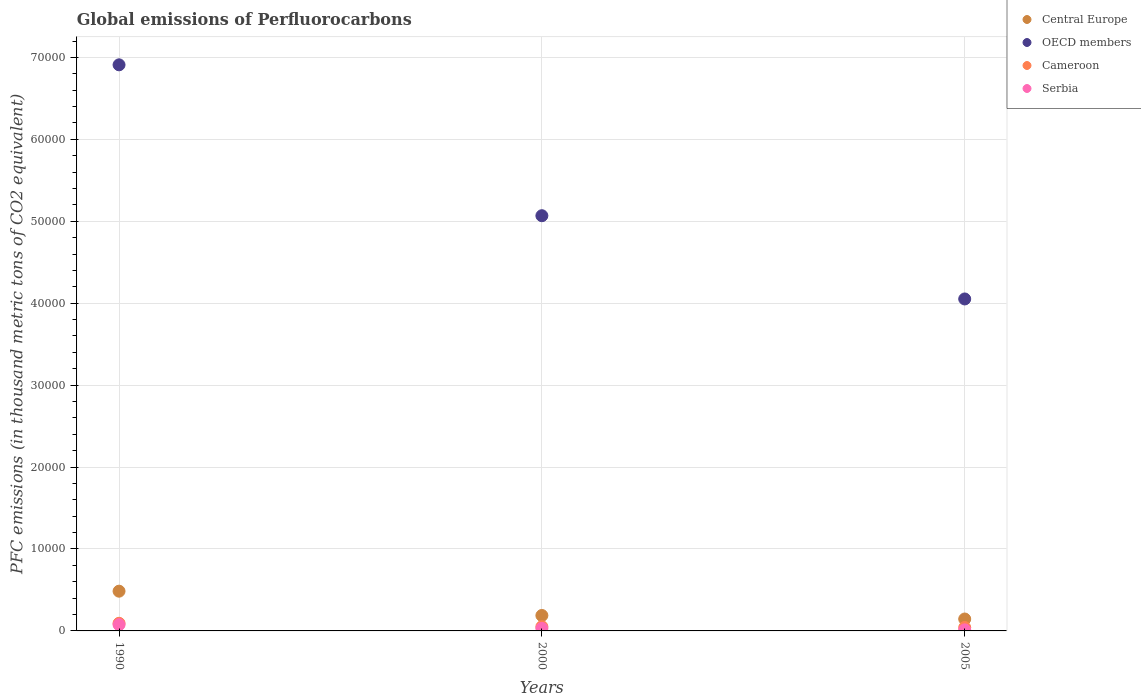Is the number of dotlines equal to the number of legend labels?
Your answer should be compact. Yes. What is the global emissions of Perfluorocarbons in OECD members in 2005?
Your answer should be compact. 4.05e+04. Across all years, what is the maximum global emissions of Perfluorocarbons in Cameroon?
Ensure brevity in your answer.  932.3. Across all years, what is the minimum global emissions of Perfluorocarbons in Cameroon?
Keep it short and to the point. 417.5. In which year was the global emissions of Perfluorocarbons in Cameroon maximum?
Your answer should be very brief. 1990. What is the total global emissions of Perfluorocarbons in Serbia in the graph?
Make the answer very short. 1197. What is the difference between the global emissions of Perfluorocarbons in Cameroon in 1990 and that in 2005?
Make the answer very short. 514.8. What is the difference between the global emissions of Perfluorocarbons in Serbia in 1990 and the global emissions of Perfluorocarbons in OECD members in 2000?
Offer a terse response. -4.99e+04. What is the average global emissions of Perfluorocarbons in OECD members per year?
Give a very brief answer. 5.34e+04. In the year 2005, what is the difference between the global emissions of Perfluorocarbons in OECD members and global emissions of Perfluorocarbons in Serbia?
Your answer should be very brief. 4.04e+04. What is the ratio of the global emissions of Perfluorocarbons in OECD members in 1990 to that in 2000?
Provide a short and direct response. 1.36. Is the global emissions of Perfluorocarbons in Serbia in 1990 less than that in 2005?
Provide a short and direct response. No. Is the difference between the global emissions of Perfluorocarbons in OECD members in 1990 and 2005 greater than the difference between the global emissions of Perfluorocarbons in Serbia in 1990 and 2005?
Your response must be concise. Yes. What is the difference between the highest and the second highest global emissions of Perfluorocarbons in OECD members?
Your answer should be compact. 1.84e+04. What is the difference between the highest and the lowest global emissions of Perfluorocarbons in Central Europe?
Give a very brief answer. 3396.8. Is the sum of the global emissions of Perfluorocarbons in Central Europe in 1990 and 2005 greater than the maximum global emissions of Perfluorocarbons in Cameroon across all years?
Give a very brief answer. Yes. Is it the case that in every year, the sum of the global emissions of Perfluorocarbons in Cameroon and global emissions of Perfluorocarbons in Serbia  is greater than the sum of global emissions of Perfluorocarbons in OECD members and global emissions of Perfluorocarbons in Central Europe?
Keep it short and to the point. No. Is it the case that in every year, the sum of the global emissions of Perfluorocarbons in Cameroon and global emissions of Perfluorocarbons in Serbia  is greater than the global emissions of Perfluorocarbons in OECD members?
Give a very brief answer. No. Does the global emissions of Perfluorocarbons in Cameroon monotonically increase over the years?
Your answer should be very brief. No. Is the global emissions of Perfluorocarbons in Serbia strictly less than the global emissions of Perfluorocarbons in OECD members over the years?
Make the answer very short. Yes. How many years are there in the graph?
Your answer should be compact. 3. Are the values on the major ticks of Y-axis written in scientific E-notation?
Your answer should be compact. No. How are the legend labels stacked?
Provide a short and direct response. Vertical. What is the title of the graph?
Offer a terse response. Global emissions of Perfluorocarbons. What is the label or title of the Y-axis?
Your answer should be compact. PFC emissions (in thousand metric tons of CO2 equivalent). What is the PFC emissions (in thousand metric tons of CO2 equivalent) of Central Europe in 1990?
Your answer should be compact. 4850.4. What is the PFC emissions (in thousand metric tons of CO2 equivalent) of OECD members in 1990?
Provide a short and direct response. 6.91e+04. What is the PFC emissions (in thousand metric tons of CO2 equivalent) of Cameroon in 1990?
Offer a terse response. 932.3. What is the PFC emissions (in thousand metric tons of CO2 equivalent) in Serbia in 1990?
Provide a short and direct response. 761.9. What is the PFC emissions (in thousand metric tons of CO2 equivalent) of Central Europe in 2000?
Your response must be concise. 1884.7. What is the PFC emissions (in thousand metric tons of CO2 equivalent) of OECD members in 2000?
Your answer should be very brief. 5.07e+04. What is the PFC emissions (in thousand metric tons of CO2 equivalent) of Cameroon in 2000?
Offer a terse response. 514.7. What is the PFC emissions (in thousand metric tons of CO2 equivalent) of Serbia in 2000?
Provide a succinct answer. 306.1. What is the PFC emissions (in thousand metric tons of CO2 equivalent) of Central Europe in 2005?
Provide a succinct answer. 1453.6. What is the PFC emissions (in thousand metric tons of CO2 equivalent) in OECD members in 2005?
Offer a terse response. 4.05e+04. What is the PFC emissions (in thousand metric tons of CO2 equivalent) in Cameroon in 2005?
Offer a very short reply. 417.5. What is the PFC emissions (in thousand metric tons of CO2 equivalent) in Serbia in 2005?
Make the answer very short. 129. Across all years, what is the maximum PFC emissions (in thousand metric tons of CO2 equivalent) in Central Europe?
Your answer should be very brief. 4850.4. Across all years, what is the maximum PFC emissions (in thousand metric tons of CO2 equivalent) in OECD members?
Ensure brevity in your answer.  6.91e+04. Across all years, what is the maximum PFC emissions (in thousand metric tons of CO2 equivalent) of Cameroon?
Give a very brief answer. 932.3. Across all years, what is the maximum PFC emissions (in thousand metric tons of CO2 equivalent) of Serbia?
Your answer should be very brief. 761.9. Across all years, what is the minimum PFC emissions (in thousand metric tons of CO2 equivalent) in Central Europe?
Your answer should be compact. 1453.6. Across all years, what is the minimum PFC emissions (in thousand metric tons of CO2 equivalent) of OECD members?
Your answer should be very brief. 4.05e+04. Across all years, what is the minimum PFC emissions (in thousand metric tons of CO2 equivalent) in Cameroon?
Make the answer very short. 417.5. Across all years, what is the minimum PFC emissions (in thousand metric tons of CO2 equivalent) of Serbia?
Keep it short and to the point. 129. What is the total PFC emissions (in thousand metric tons of CO2 equivalent) of Central Europe in the graph?
Your response must be concise. 8188.7. What is the total PFC emissions (in thousand metric tons of CO2 equivalent) in OECD members in the graph?
Keep it short and to the point. 1.60e+05. What is the total PFC emissions (in thousand metric tons of CO2 equivalent) in Cameroon in the graph?
Your answer should be very brief. 1864.5. What is the total PFC emissions (in thousand metric tons of CO2 equivalent) of Serbia in the graph?
Provide a short and direct response. 1197. What is the difference between the PFC emissions (in thousand metric tons of CO2 equivalent) in Central Europe in 1990 and that in 2000?
Give a very brief answer. 2965.7. What is the difference between the PFC emissions (in thousand metric tons of CO2 equivalent) in OECD members in 1990 and that in 2000?
Your response must be concise. 1.84e+04. What is the difference between the PFC emissions (in thousand metric tons of CO2 equivalent) in Cameroon in 1990 and that in 2000?
Provide a succinct answer. 417.6. What is the difference between the PFC emissions (in thousand metric tons of CO2 equivalent) in Serbia in 1990 and that in 2000?
Your answer should be very brief. 455.8. What is the difference between the PFC emissions (in thousand metric tons of CO2 equivalent) of Central Europe in 1990 and that in 2005?
Offer a terse response. 3396.8. What is the difference between the PFC emissions (in thousand metric tons of CO2 equivalent) of OECD members in 1990 and that in 2005?
Your answer should be compact. 2.86e+04. What is the difference between the PFC emissions (in thousand metric tons of CO2 equivalent) of Cameroon in 1990 and that in 2005?
Your answer should be compact. 514.8. What is the difference between the PFC emissions (in thousand metric tons of CO2 equivalent) of Serbia in 1990 and that in 2005?
Your response must be concise. 632.9. What is the difference between the PFC emissions (in thousand metric tons of CO2 equivalent) in Central Europe in 2000 and that in 2005?
Your answer should be compact. 431.1. What is the difference between the PFC emissions (in thousand metric tons of CO2 equivalent) in OECD members in 2000 and that in 2005?
Provide a succinct answer. 1.02e+04. What is the difference between the PFC emissions (in thousand metric tons of CO2 equivalent) of Cameroon in 2000 and that in 2005?
Keep it short and to the point. 97.2. What is the difference between the PFC emissions (in thousand metric tons of CO2 equivalent) of Serbia in 2000 and that in 2005?
Your response must be concise. 177.1. What is the difference between the PFC emissions (in thousand metric tons of CO2 equivalent) in Central Europe in 1990 and the PFC emissions (in thousand metric tons of CO2 equivalent) in OECD members in 2000?
Offer a very short reply. -4.58e+04. What is the difference between the PFC emissions (in thousand metric tons of CO2 equivalent) in Central Europe in 1990 and the PFC emissions (in thousand metric tons of CO2 equivalent) in Cameroon in 2000?
Offer a very short reply. 4335.7. What is the difference between the PFC emissions (in thousand metric tons of CO2 equivalent) in Central Europe in 1990 and the PFC emissions (in thousand metric tons of CO2 equivalent) in Serbia in 2000?
Ensure brevity in your answer.  4544.3. What is the difference between the PFC emissions (in thousand metric tons of CO2 equivalent) in OECD members in 1990 and the PFC emissions (in thousand metric tons of CO2 equivalent) in Cameroon in 2000?
Your answer should be very brief. 6.86e+04. What is the difference between the PFC emissions (in thousand metric tons of CO2 equivalent) in OECD members in 1990 and the PFC emissions (in thousand metric tons of CO2 equivalent) in Serbia in 2000?
Give a very brief answer. 6.88e+04. What is the difference between the PFC emissions (in thousand metric tons of CO2 equivalent) of Cameroon in 1990 and the PFC emissions (in thousand metric tons of CO2 equivalent) of Serbia in 2000?
Provide a succinct answer. 626.2. What is the difference between the PFC emissions (in thousand metric tons of CO2 equivalent) of Central Europe in 1990 and the PFC emissions (in thousand metric tons of CO2 equivalent) of OECD members in 2005?
Offer a very short reply. -3.57e+04. What is the difference between the PFC emissions (in thousand metric tons of CO2 equivalent) of Central Europe in 1990 and the PFC emissions (in thousand metric tons of CO2 equivalent) of Cameroon in 2005?
Offer a terse response. 4432.9. What is the difference between the PFC emissions (in thousand metric tons of CO2 equivalent) in Central Europe in 1990 and the PFC emissions (in thousand metric tons of CO2 equivalent) in Serbia in 2005?
Give a very brief answer. 4721.4. What is the difference between the PFC emissions (in thousand metric tons of CO2 equivalent) in OECD members in 1990 and the PFC emissions (in thousand metric tons of CO2 equivalent) in Cameroon in 2005?
Ensure brevity in your answer.  6.87e+04. What is the difference between the PFC emissions (in thousand metric tons of CO2 equivalent) in OECD members in 1990 and the PFC emissions (in thousand metric tons of CO2 equivalent) in Serbia in 2005?
Keep it short and to the point. 6.90e+04. What is the difference between the PFC emissions (in thousand metric tons of CO2 equivalent) of Cameroon in 1990 and the PFC emissions (in thousand metric tons of CO2 equivalent) of Serbia in 2005?
Provide a succinct answer. 803.3. What is the difference between the PFC emissions (in thousand metric tons of CO2 equivalent) in Central Europe in 2000 and the PFC emissions (in thousand metric tons of CO2 equivalent) in OECD members in 2005?
Ensure brevity in your answer.  -3.86e+04. What is the difference between the PFC emissions (in thousand metric tons of CO2 equivalent) in Central Europe in 2000 and the PFC emissions (in thousand metric tons of CO2 equivalent) in Cameroon in 2005?
Make the answer very short. 1467.2. What is the difference between the PFC emissions (in thousand metric tons of CO2 equivalent) of Central Europe in 2000 and the PFC emissions (in thousand metric tons of CO2 equivalent) of Serbia in 2005?
Provide a succinct answer. 1755.7. What is the difference between the PFC emissions (in thousand metric tons of CO2 equivalent) of OECD members in 2000 and the PFC emissions (in thousand metric tons of CO2 equivalent) of Cameroon in 2005?
Ensure brevity in your answer.  5.03e+04. What is the difference between the PFC emissions (in thousand metric tons of CO2 equivalent) in OECD members in 2000 and the PFC emissions (in thousand metric tons of CO2 equivalent) in Serbia in 2005?
Give a very brief answer. 5.06e+04. What is the difference between the PFC emissions (in thousand metric tons of CO2 equivalent) in Cameroon in 2000 and the PFC emissions (in thousand metric tons of CO2 equivalent) in Serbia in 2005?
Your answer should be very brief. 385.7. What is the average PFC emissions (in thousand metric tons of CO2 equivalent) in Central Europe per year?
Provide a succinct answer. 2729.57. What is the average PFC emissions (in thousand metric tons of CO2 equivalent) of OECD members per year?
Ensure brevity in your answer.  5.34e+04. What is the average PFC emissions (in thousand metric tons of CO2 equivalent) in Cameroon per year?
Ensure brevity in your answer.  621.5. What is the average PFC emissions (in thousand metric tons of CO2 equivalent) of Serbia per year?
Offer a very short reply. 399. In the year 1990, what is the difference between the PFC emissions (in thousand metric tons of CO2 equivalent) in Central Europe and PFC emissions (in thousand metric tons of CO2 equivalent) in OECD members?
Your answer should be compact. -6.42e+04. In the year 1990, what is the difference between the PFC emissions (in thousand metric tons of CO2 equivalent) in Central Europe and PFC emissions (in thousand metric tons of CO2 equivalent) in Cameroon?
Your answer should be compact. 3918.1. In the year 1990, what is the difference between the PFC emissions (in thousand metric tons of CO2 equivalent) in Central Europe and PFC emissions (in thousand metric tons of CO2 equivalent) in Serbia?
Provide a short and direct response. 4088.5. In the year 1990, what is the difference between the PFC emissions (in thousand metric tons of CO2 equivalent) in OECD members and PFC emissions (in thousand metric tons of CO2 equivalent) in Cameroon?
Your answer should be very brief. 6.82e+04. In the year 1990, what is the difference between the PFC emissions (in thousand metric tons of CO2 equivalent) of OECD members and PFC emissions (in thousand metric tons of CO2 equivalent) of Serbia?
Provide a short and direct response. 6.83e+04. In the year 1990, what is the difference between the PFC emissions (in thousand metric tons of CO2 equivalent) in Cameroon and PFC emissions (in thousand metric tons of CO2 equivalent) in Serbia?
Offer a very short reply. 170.4. In the year 2000, what is the difference between the PFC emissions (in thousand metric tons of CO2 equivalent) of Central Europe and PFC emissions (in thousand metric tons of CO2 equivalent) of OECD members?
Offer a very short reply. -4.88e+04. In the year 2000, what is the difference between the PFC emissions (in thousand metric tons of CO2 equivalent) of Central Europe and PFC emissions (in thousand metric tons of CO2 equivalent) of Cameroon?
Your response must be concise. 1370. In the year 2000, what is the difference between the PFC emissions (in thousand metric tons of CO2 equivalent) in Central Europe and PFC emissions (in thousand metric tons of CO2 equivalent) in Serbia?
Ensure brevity in your answer.  1578.6. In the year 2000, what is the difference between the PFC emissions (in thousand metric tons of CO2 equivalent) in OECD members and PFC emissions (in thousand metric tons of CO2 equivalent) in Cameroon?
Offer a very short reply. 5.02e+04. In the year 2000, what is the difference between the PFC emissions (in thousand metric tons of CO2 equivalent) in OECD members and PFC emissions (in thousand metric tons of CO2 equivalent) in Serbia?
Your answer should be compact. 5.04e+04. In the year 2000, what is the difference between the PFC emissions (in thousand metric tons of CO2 equivalent) of Cameroon and PFC emissions (in thousand metric tons of CO2 equivalent) of Serbia?
Give a very brief answer. 208.6. In the year 2005, what is the difference between the PFC emissions (in thousand metric tons of CO2 equivalent) in Central Europe and PFC emissions (in thousand metric tons of CO2 equivalent) in OECD members?
Offer a terse response. -3.91e+04. In the year 2005, what is the difference between the PFC emissions (in thousand metric tons of CO2 equivalent) of Central Europe and PFC emissions (in thousand metric tons of CO2 equivalent) of Cameroon?
Offer a very short reply. 1036.1. In the year 2005, what is the difference between the PFC emissions (in thousand metric tons of CO2 equivalent) of Central Europe and PFC emissions (in thousand metric tons of CO2 equivalent) of Serbia?
Ensure brevity in your answer.  1324.6. In the year 2005, what is the difference between the PFC emissions (in thousand metric tons of CO2 equivalent) in OECD members and PFC emissions (in thousand metric tons of CO2 equivalent) in Cameroon?
Give a very brief answer. 4.01e+04. In the year 2005, what is the difference between the PFC emissions (in thousand metric tons of CO2 equivalent) of OECD members and PFC emissions (in thousand metric tons of CO2 equivalent) of Serbia?
Offer a very short reply. 4.04e+04. In the year 2005, what is the difference between the PFC emissions (in thousand metric tons of CO2 equivalent) in Cameroon and PFC emissions (in thousand metric tons of CO2 equivalent) in Serbia?
Offer a very short reply. 288.5. What is the ratio of the PFC emissions (in thousand metric tons of CO2 equivalent) of Central Europe in 1990 to that in 2000?
Your answer should be very brief. 2.57. What is the ratio of the PFC emissions (in thousand metric tons of CO2 equivalent) of OECD members in 1990 to that in 2000?
Your answer should be very brief. 1.36. What is the ratio of the PFC emissions (in thousand metric tons of CO2 equivalent) in Cameroon in 1990 to that in 2000?
Ensure brevity in your answer.  1.81. What is the ratio of the PFC emissions (in thousand metric tons of CO2 equivalent) of Serbia in 1990 to that in 2000?
Your answer should be compact. 2.49. What is the ratio of the PFC emissions (in thousand metric tons of CO2 equivalent) in Central Europe in 1990 to that in 2005?
Offer a terse response. 3.34. What is the ratio of the PFC emissions (in thousand metric tons of CO2 equivalent) of OECD members in 1990 to that in 2005?
Your answer should be compact. 1.71. What is the ratio of the PFC emissions (in thousand metric tons of CO2 equivalent) of Cameroon in 1990 to that in 2005?
Your answer should be compact. 2.23. What is the ratio of the PFC emissions (in thousand metric tons of CO2 equivalent) in Serbia in 1990 to that in 2005?
Provide a succinct answer. 5.91. What is the ratio of the PFC emissions (in thousand metric tons of CO2 equivalent) of Central Europe in 2000 to that in 2005?
Your answer should be compact. 1.3. What is the ratio of the PFC emissions (in thousand metric tons of CO2 equivalent) in OECD members in 2000 to that in 2005?
Your response must be concise. 1.25. What is the ratio of the PFC emissions (in thousand metric tons of CO2 equivalent) in Cameroon in 2000 to that in 2005?
Provide a succinct answer. 1.23. What is the ratio of the PFC emissions (in thousand metric tons of CO2 equivalent) of Serbia in 2000 to that in 2005?
Ensure brevity in your answer.  2.37. What is the difference between the highest and the second highest PFC emissions (in thousand metric tons of CO2 equivalent) of Central Europe?
Your answer should be compact. 2965.7. What is the difference between the highest and the second highest PFC emissions (in thousand metric tons of CO2 equivalent) in OECD members?
Provide a short and direct response. 1.84e+04. What is the difference between the highest and the second highest PFC emissions (in thousand metric tons of CO2 equivalent) of Cameroon?
Your answer should be very brief. 417.6. What is the difference between the highest and the second highest PFC emissions (in thousand metric tons of CO2 equivalent) in Serbia?
Your answer should be compact. 455.8. What is the difference between the highest and the lowest PFC emissions (in thousand metric tons of CO2 equivalent) in Central Europe?
Make the answer very short. 3396.8. What is the difference between the highest and the lowest PFC emissions (in thousand metric tons of CO2 equivalent) in OECD members?
Keep it short and to the point. 2.86e+04. What is the difference between the highest and the lowest PFC emissions (in thousand metric tons of CO2 equivalent) of Cameroon?
Your answer should be very brief. 514.8. What is the difference between the highest and the lowest PFC emissions (in thousand metric tons of CO2 equivalent) in Serbia?
Make the answer very short. 632.9. 